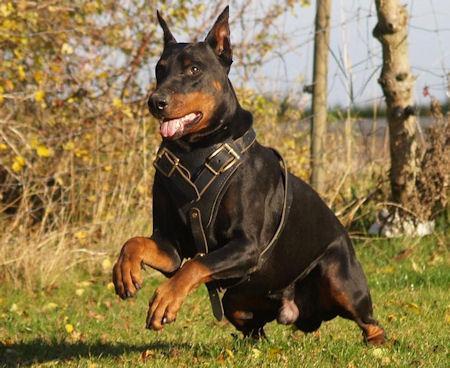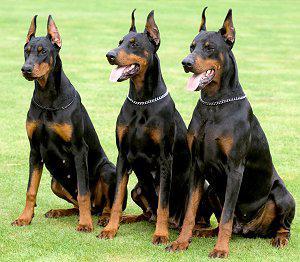The first image is the image on the left, the second image is the image on the right. For the images displayed, is the sentence "At least three dogs are dobermans with upright pointy ears, and no dogs are standing up with all four paws on the ground." factually correct? Answer yes or no. Yes. The first image is the image on the left, the second image is the image on the right. Given the left and right images, does the statement "Two dogs are standing in the grass in the image on the left." hold true? Answer yes or no. No. 